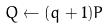<formula> <loc_0><loc_0><loc_500><loc_500>Q \leftarrow ( q + 1 ) P</formula> 